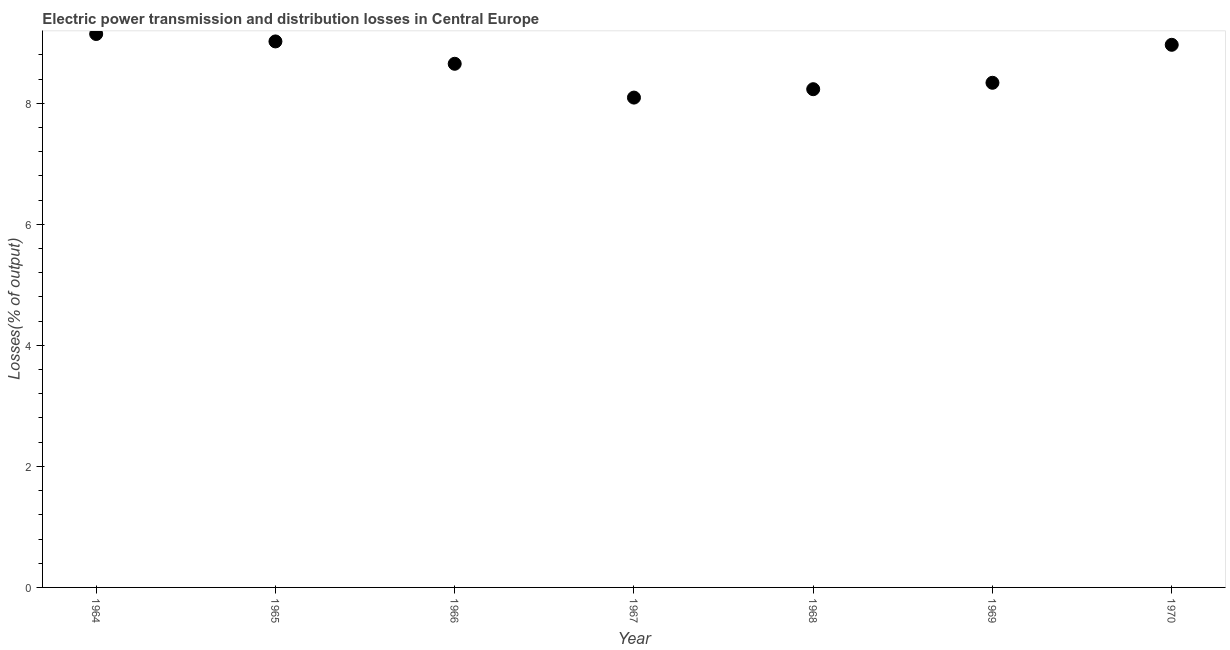What is the electric power transmission and distribution losses in 1964?
Provide a succinct answer. 9.15. Across all years, what is the maximum electric power transmission and distribution losses?
Offer a very short reply. 9.15. Across all years, what is the minimum electric power transmission and distribution losses?
Keep it short and to the point. 8.09. In which year was the electric power transmission and distribution losses maximum?
Keep it short and to the point. 1964. In which year was the electric power transmission and distribution losses minimum?
Offer a very short reply. 1967. What is the sum of the electric power transmission and distribution losses?
Offer a very short reply. 60.45. What is the difference between the electric power transmission and distribution losses in 1965 and 1967?
Keep it short and to the point. 0.93. What is the average electric power transmission and distribution losses per year?
Your answer should be very brief. 8.64. What is the median electric power transmission and distribution losses?
Give a very brief answer. 8.65. What is the ratio of the electric power transmission and distribution losses in 1968 to that in 1970?
Ensure brevity in your answer.  0.92. What is the difference between the highest and the second highest electric power transmission and distribution losses?
Offer a terse response. 0.12. Is the sum of the electric power transmission and distribution losses in 1964 and 1968 greater than the maximum electric power transmission and distribution losses across all years?
Make the answer very short. Yes. What is the difference between the highest and the lowest electric power transmission and distribution losses?
Ensure brevity in your answer.  1.05. In how many years, is the electric power transmission and distribution losses greater than the average electric power transmission and distribution losses taken over all years?
Give a very brief answer. 4. Does the electric power transmission and distribution losses monotonically increase over the years?
Ensure brevity in your answer.  No. What is the difference between two consecutive major ticks on the Y-axis?
Provide a short and direct response. 2. Are the values on the major ticks of Y-axis written in scientific E-notation?
Your answer should be very brief. No. Does the graph contain any zero values?
Your answer should be compact. No. Does the graph contain grids?
Your answer should be compact. No. What is the title of the graph?
Your answer should be compact. Electric power transmission and distribution losses in Central Europe. What is the label or title of the Y-axis?
Offer a terse response. Losses(% of output). What is the Losses(% of output) in 1964?
Your answer should be very brief. 9.15. What is the Losses(% of output) in 1965?
Your answer should be very brief. 9.02. What is the Losses(% of output) in 1966?
Provide a short and direct response. 8.65. What is the Losses(% of output) in 1967?
Keep it short and to the point. 8.09. What is the Losses(% of output) in 1968?
Your answer should be very brief. 8.23. What is the Losses(% of output) in 1969?
Make the answer very short. 8.34. What is the Losses(% of output) in 1970?
Provide a short and direct response. 8.97. What is the difference between the Losses(% of output) in 1964 and 1965?
Your answer should be compact. 0.12. What is the difference between the Losses(% of output) in 1964 and 1966?
Keep it short and to the point. 0.49. What is the difference between the Losses(% of output) in 1964 and 1967?
Keep it short and to the point. 1.05. What is the difference between the Losses(% of output) in 1964 and 1968?
Provide a succinct answer. 0.91. What is the difference between the Losses(% of output) in 1964 and 1969?
Make the answer very short. 0.81. What is the difference between the Losses(% of output) in 1964 and 1970?
Offer a terse response. 0.18. What is the difference between the Losses(% of output) in 1965 and 1966?
Your answer should be very brief. 0.37. What is the difference between the Losses(% of output) in 1965 and 1967?
Your answer should be very brief. 0.93. What is the difference between the Losses(% of output) in 1965 and 1968?
Offer a very short reply. 0.79. What is the difference between the Losses(% of output) in 1965 and 1969?
Your answer should be very brief. 0.68. What is the difference between the Losses(% of output) in 1965 and 1970?
Your answer should be compact. 0.06. What is the difference between the Losses(% of output) in 1966 and 1967?
Provide a succinct answer. 0.56. What is the difference between the Losses(% of output) in 1966 and 1968?
Keep it short and to the point. 0.42. What is the difference between the Losses(% of output) in 1966 and 1969?
Make the answer very short. 0.31. What is the difference between the Losses(% of output) in 1966 and 1970?
Ensure brevity in your answer.  -0.31. What is the difference between the Losses(% of output) in 1967 and 1968?
Provide a short and direct response. -0.14. What is the difference between the Losses(% of output) in 1967 and 1969?
Your answer should be compact. -0.24. What is the difference between the Losses(% of output) in 1967 and 1970?
Provide a succinct answer. -0.87. What is the difference between the Losses(% of output) in 1968 and 1969?
Provide a short and direct response. -0.11. What is the difference between the Losses(% of output) in 1968 and 1970?
Give a very brief answer. -0.73. What is the difference between the Losses(% of output) in 1969 and 1970?
Give a very brief answer. -0.63. What is the ratio of the Losses(% of output) in 1964 to that in 1966?
Offer a very short reply. 1.06. What is the ratio of the Losses(% of output) in 1964 to that in 1967?
Provide a succinct answer. 1.13. What is the ratio of the Losses(% of output) in 1964 to that in 1968?
Keep it short and to the point. 1.11. What is the ratio of the Losses(% of output) in 1964 to that in 1969?
Offer a very short reply. 1.1. What is the ratio of the Losses(% of output) in 1964 to that in 1970?
Ensure brevity in your answer.  1.02. What is the ratio of the Losses(% of output) in 1965 to that in 1966?
Make the answer very short. 1.04. What is the ratio of the Losses(% of output) in 1965 to that in 1967?
Provide a short and direct response. 1.11. What is the ratio of the Losses(% of output) in 1965 to that in 1968?
Make the answer very short. 1.1. What is the ratio of the Losses(% of output) in 1965 to that in 1969?
Ensure brevity in your answer.  1.08. What is the ratio of the Losses(% of output) in 1965 to that in 1970?
Your response must be concise. 1.01. What is the ratio of the Losses(% of output) in 1966 to that in 1967?
Keep it short and to the point. 1.07. What is the ratio of the Losses(% of output) in 1966 to that in 1968?
Make the answer very short. 1.05. What is the ratio of the Losses(% of output) in 1966 to that in 1969?
Provide a succinct answer. 1.04. What is the ratio of the Losses(% of output) in 1966 to that in 1970?
Ensure brevity in your answer.  0.96. What is the ratio of the Losses(% of output) in 1967 to that in 1969?
Offer a terse response. 0.97. What is the ratio of the Losses(% of output) in 1967 to that in 1970?
Your answer should be compact. 0.9. What is the ratio of the Losses(% of output) in 1968 to that in 1970?
Keep it short and to the point. 0.92. What is the ratio of the Losses(% of output) in 1969 to that in 1970?
Provide a short and direct response. 0.93. 